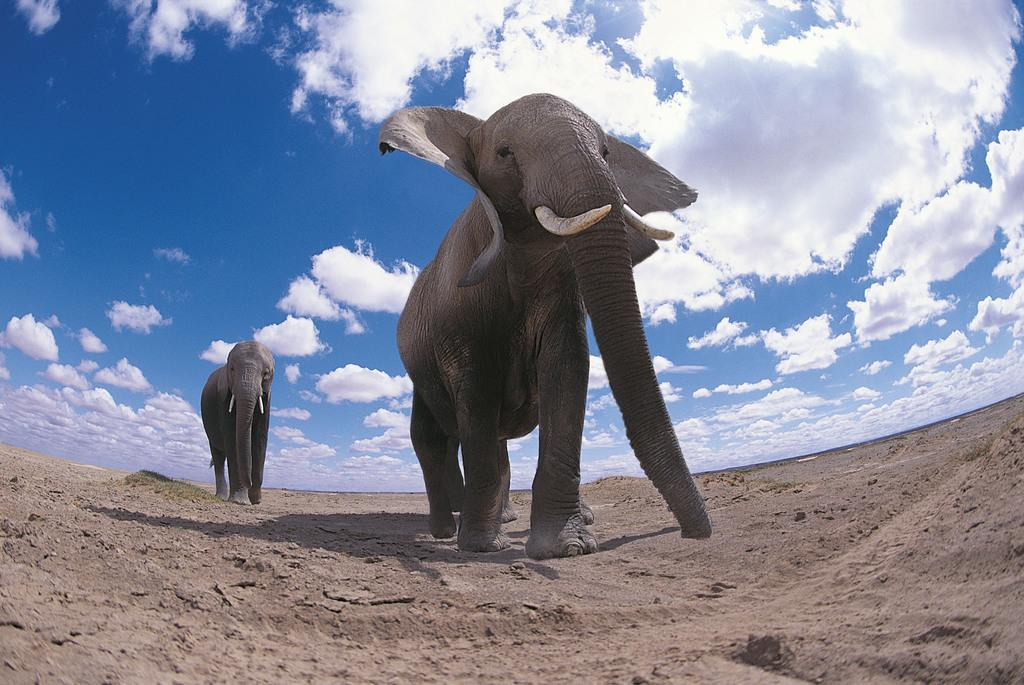How many elephants are in the image? There are two elephants visible in the image. Where are the elephants located? The elephants are on the land. What is visible at the top of the image? The sky is visible at the top of the image. What can be seen in the sky? Clouds are visible in the sky. What type of rake is being used by the elephants in the image? There is no rake present in the image; the elephants are not using any tools or equipment. How does the loss of the jellyfish affect the elephants in the image? There is no mention of jellyfish or any loss in the image, so it is not possible to determine any impact on the elephants. 